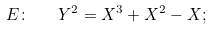<formula> <loc_0><loc_0><loc_500><loc_500>E \colon \quad Y ^ { 2 } = X ^ { 3 } + X ^ { 2 } - X ;</formula> 